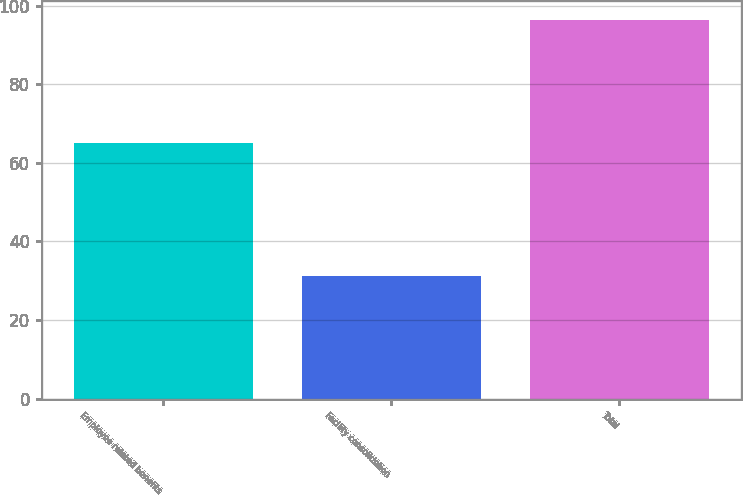Convert chart. <chart><loc_0><loc_0><loc_500><loc_500><bar_chart><fcel>Employee related benefits<fcel>Facility consolidation<fcel>Total<nl><fcel>65.1<fcel>31.2<fcel>96.3<nl></chart> 